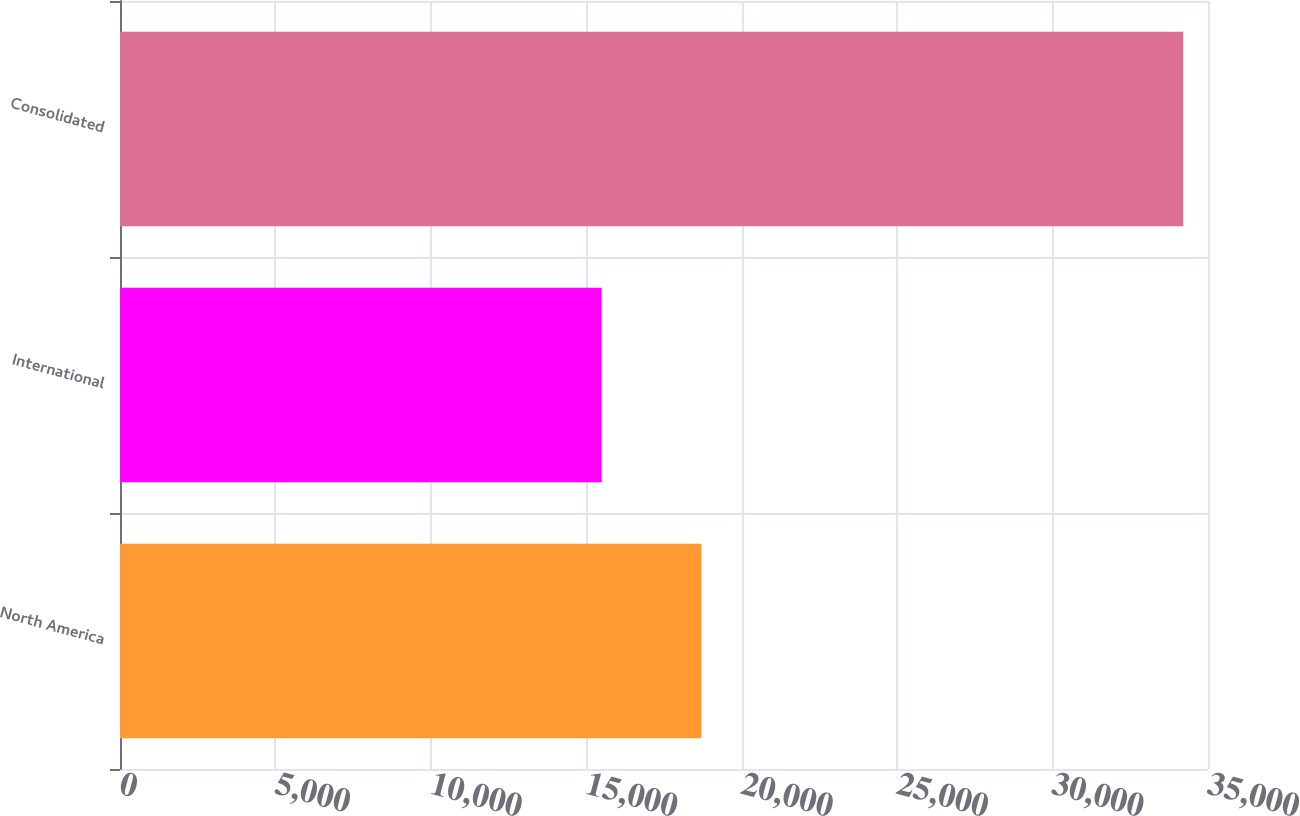Convert chart. <chart><loc_0><loc_0><loc_500><loc_500><bar_chart><fcel>North America<fcel>International<fcel>Consolidated<nl><fcel>18707<fcel>15497<fcel>34204<nl></chart> 